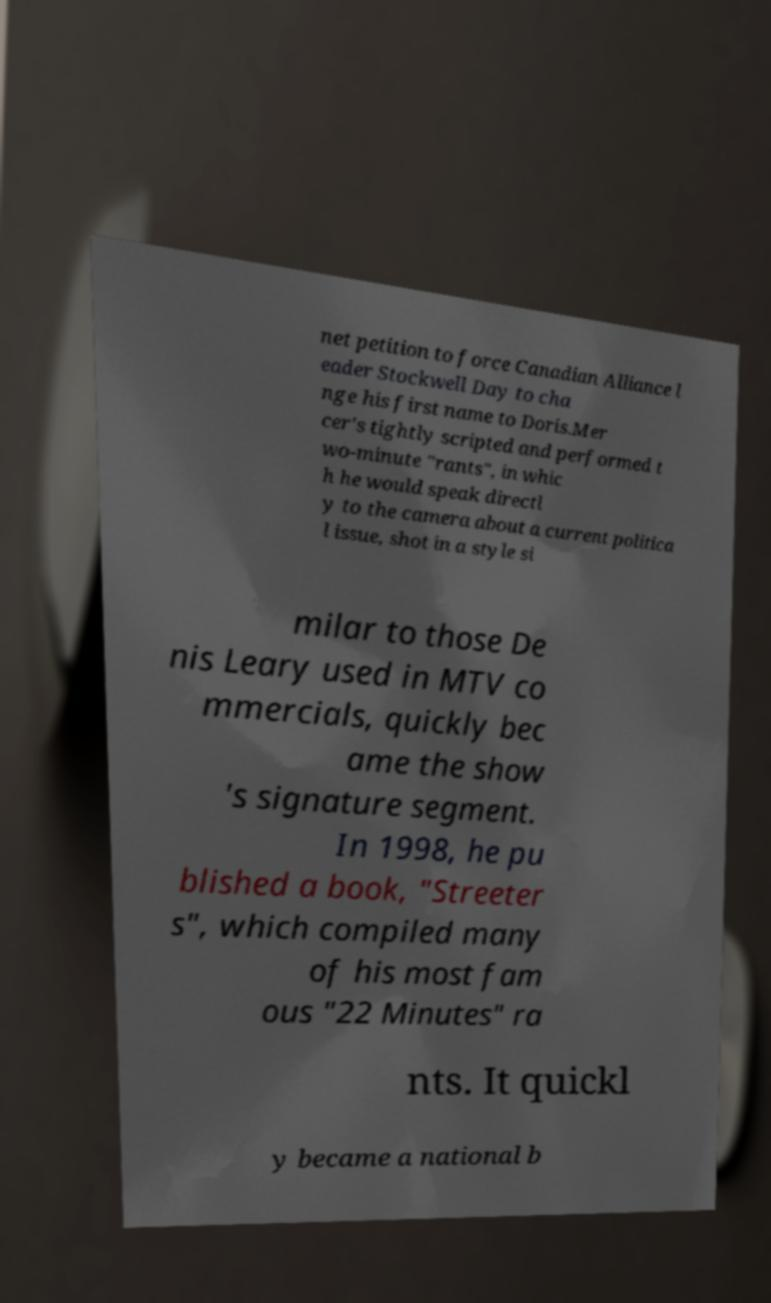Please identify and transcribe the text found in this image. net petition to force Canadian Alliance l eader Stockwell Day to cha nge his first name to Doris.Mer cer's tightly scripted and performed t wo-minute "rants", in whic h he would speak directl y to the camera about a current politica l issue, shot in a style si milar to those De nis Leary used in MTV co mmercials, quickly bec ame the show 's signature segment. In 1998, he pu blished a book, "Streeter s", which compiled many of his most fam ous "22 Minutes" ra nts. It quickl y became a national b 